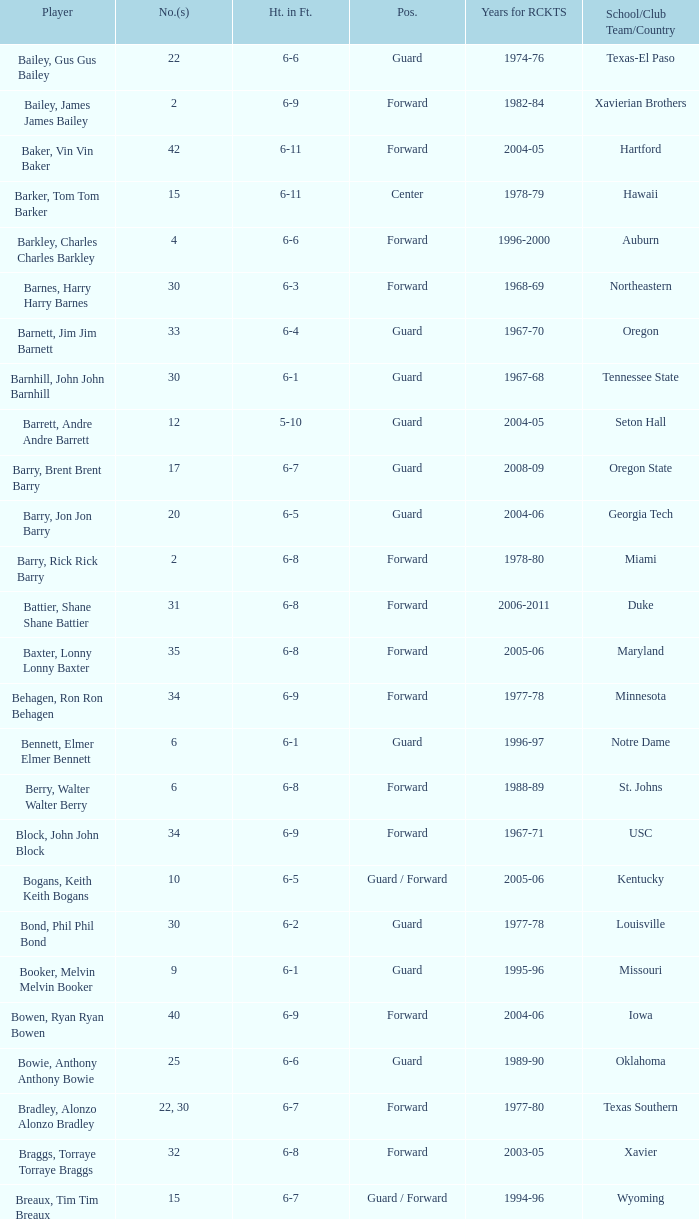What position is number 35 whose height is 6-6? Forward. 